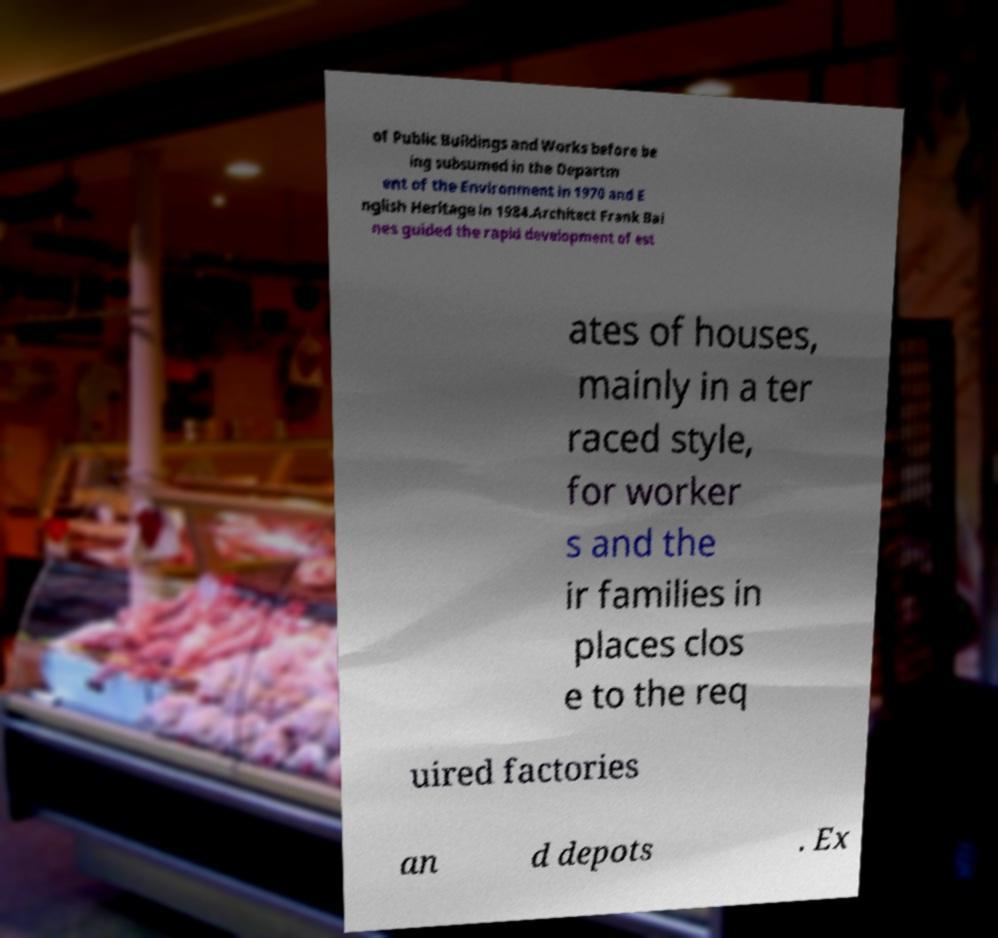I need the written content from this picture converted into text. Can you do that? of Public Buildings and Works before be ing subsumed in the Departm ent of the Environment in 1970 and E nglish Heritage in 1984.Architect Frank Bai nes guided the rapid development of est ates of houses, mainly in a ter raced style, for worker s and the ir families in places clos e to the req uired factories an d depots . Ex 